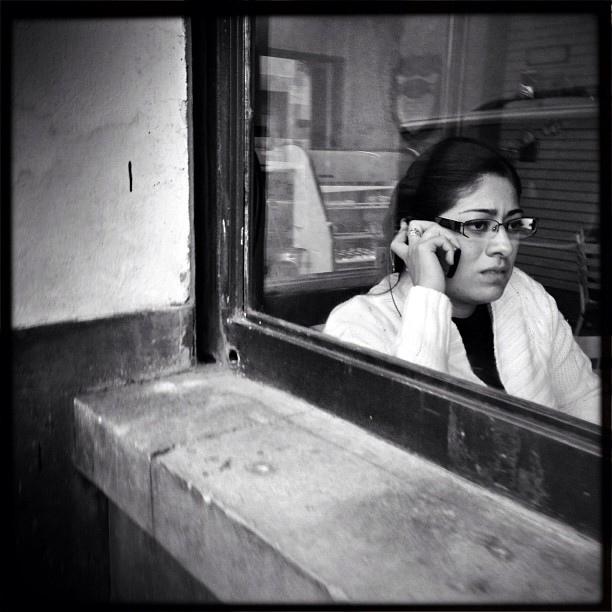Is the woman wearing glasses?
Concise answer only. Yes. What type of place would this woman be?
Concise answer only. Restaurant. What color is the photo?
Keep it brief. Black and white. 